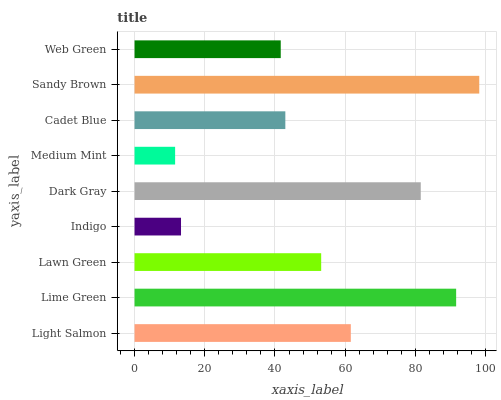Is Medium Mint the minimum?
Answer yes or no. Yes. Is Sandy Brown the maximum?
Answer yes or no. Yes. Is Lime Green the minimum?
Answer yes or no. No. Is Lime Green the maximum?
Answer yes or no. No. Is Lime Green greater than Light Salmon?
Answer yes or no. Yes. Is Light Salmon less than Lime Green?
Answer yes or no. Yes. Is Light Salmon greater than Lime Green?
Answer yes or no. No. Is Lime Green less than Light Salmon?
Answer yes or no. No. Is Lawn Green the high median?
Answer yes or no. Yes. Is Lawn Green the low median?
Answer yes or no. Yes. Is Light Salmon the high median?
Answer yes or no. No. Is Medium Mint the low median?
Answer yes or no. No. 